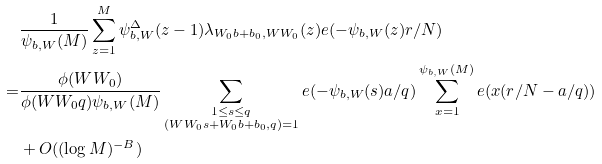<formula> <loc_0><loc_0><loc_500><loc_500>& \frac { 1 } { \psi _ { b , W } ( M ) } \sum _ { z = 1 } ^ { M } \psi _ { b , W } ^ { \Delta } ( z - 1 ) \lambda _ { W _ { 0 } b + b _ { 0 } , W W _ { 0 } } ( z ) e ( - \psi _ { b , W } ( z ) r / N ) \\ = & \frac { \phi ( W W _ { 0 } ) } { \phi ( W W _ { 0 } q ) \psi _ { b , W } ( M ) } \sum _ { \substack { 1 \leq s \leq q \\ ( W W _ { 0 } s + W _ { 0 } b + b _ { 0 } , q ) = 1 } } e ( - \psi _ { b , W } ( s ) a / q ) \sum _ { x = 1 } ^ { \psi _ { b , W } ( M ) } e ( x ( r / N - a / q ) ) \\ & + O ( ( \log M ) ^ { - B } )</formula> 